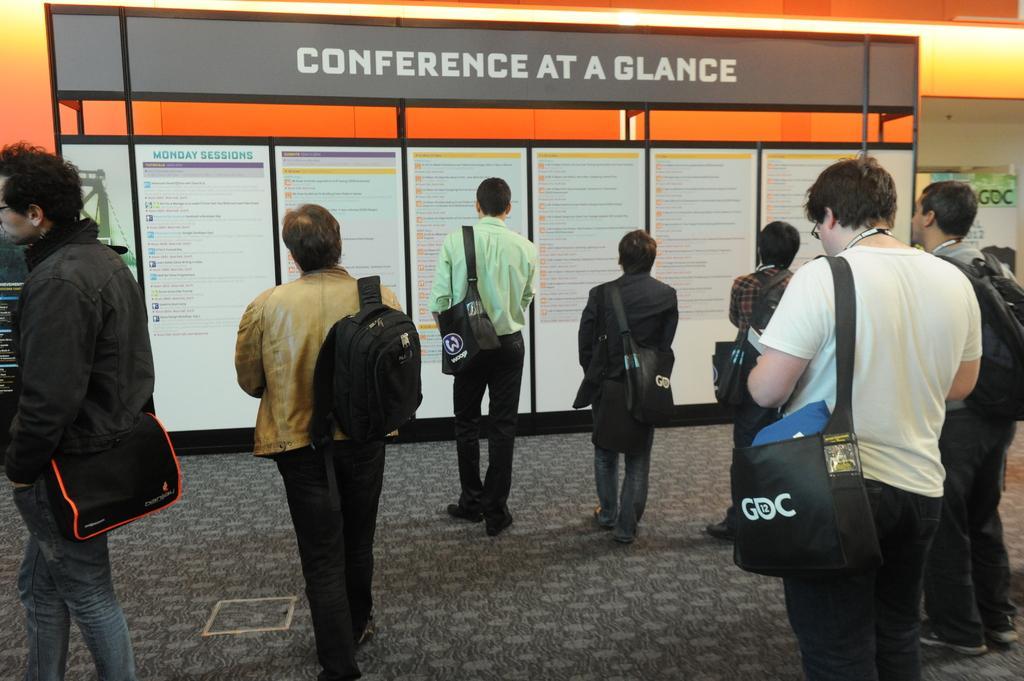How would you summarize this image in a sentence or two? In this picture I can see a group of people are standing. These people are carrying bags. In the background I can see a board which has some names written on it. 